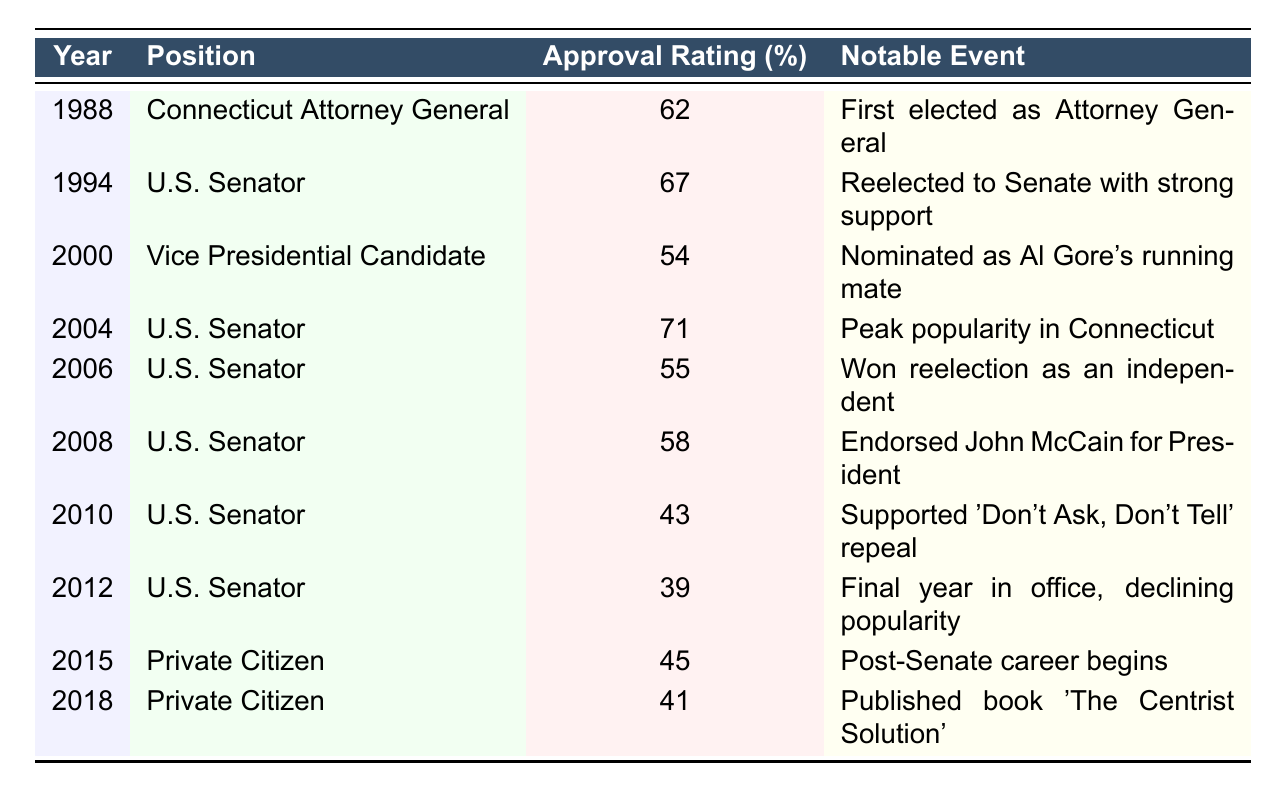What was Joe Lieberman's highest approval rating during his political career? The highest approval rating in the table is found in the year 2004, where it reached 71%.
Answer: 71% In which year did Joe Lieberman serve as a Vice Presidential Candidate? According to the table, Joe Lieberman was a Vice Presidential Candidate in the year 2000.
Answer: 2000 What was Joe Lieberman's approval rating in the year he first elected as Attorney General? The table shows that in 1988, when Joe Lieberman was first elected as Attorney General, his approval rating was 62%.
Answer: 62% Which notable event corresponds with the lowest recorded approval rating for Joe Lieberman? The lowest recorded approval rating is in 2012 at 39%, which corresponds to his final year in office and declining popularity.
Answer: 39% How much did Joe Lieberman's approval rating decrease from 2004 to 2012? In 2004, his approval was 71%, and in 2012, it was 39%. The decrease is 71 - 39 = 32 percentage points.
Answer: 32 percentage points Was Joe Lieberman's approval rating ever below 50% during his tenure as a U.S. Senator? Yes, based on the table, his approval rating was below 50% in 2010 (43%) and 2012 (39%).
Answer: Yes What was the trend of Joe Lieberman's approval ratings from 2000 to 2012? Analyzing the data from 2000 (54%) to 2012 (39%), approval ratings show a decline over this period, starting at 54% and ending at 39%.
Answer: Decline What was Joe Lieberman's approval rating as a Private Citizen in 2015, and how did it compare to 2018? His approval rating as a Private Citizen in 2015 was 45%. By 2018, it dropped to 41%. This indicates a decrease of 4 percentage points over three years.
Answer: 45%, 41% (decrease of 4 percentage points) What is the average approval rating for Joe Lieberman during his years as a U.S. Senator? The years as a U.S. Senator listed are 1994, 2000, 2004, 2006, 2008, and 2010, with corresponding ratings of 67%, 54%, 71%, 55%, 58%, and 43%, respectively. The average is (67 + 54 + 71 + 55 + 58 + 43) / 6 = 58%.
Answer: 58% Did Joe Lieberman's approval rating ever peak during his career? Yes, the highest point of his approval rating was 71% in 2004, indicating it peaked that year.
Answer: Yes 